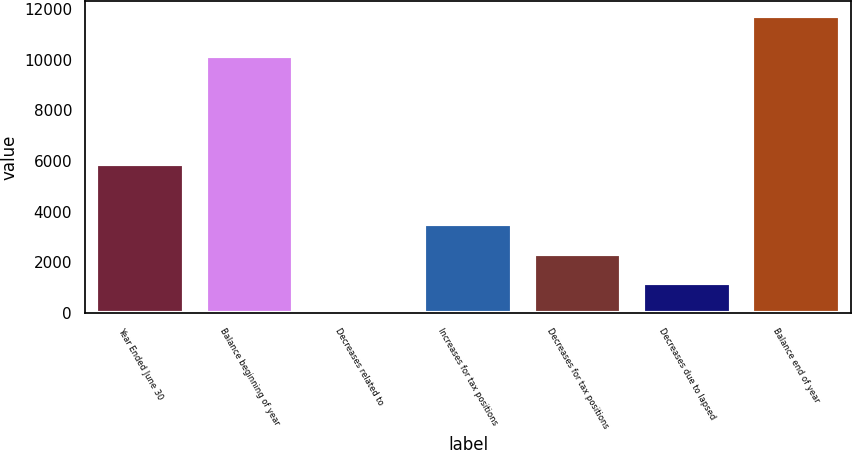Convert chart. <chart><loc_0><loc_0><loc_500><loc_500><bar_chart><fcel>Year Ended June 30<fcel>Balance beginning of year<fcel>Decreases related to<fcel>Increases for tax positions<fcel>Decreases for tax positions<fcel>Decreases due to lapsed<fcel>Balance end of year<nl><fcel>5870.5<fcel>10164<fcel>4<fcel>3523.9<fcel>2350.6<fcel>1177.3<fcel>11737<nl></chart> 